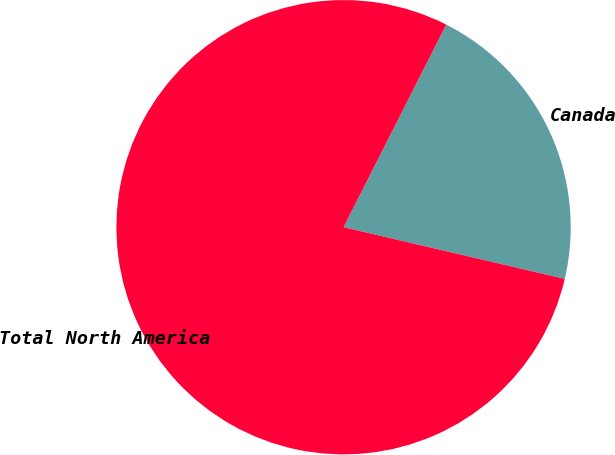<chart> <loc_0><loc_0><loc_500><loc_500><pie_chart><fcel>Canada<fcel>Total North America<nl><fcel>21.19%<fcel>78.81%<nl></chart> 